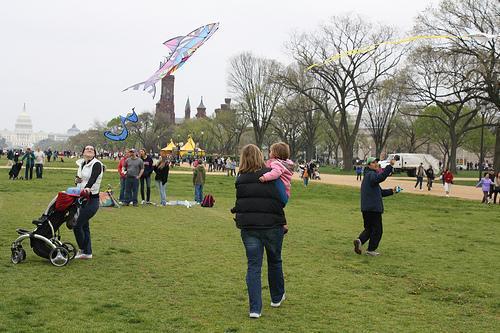How many kites are in the air?
Give a very brief answer. 3. 